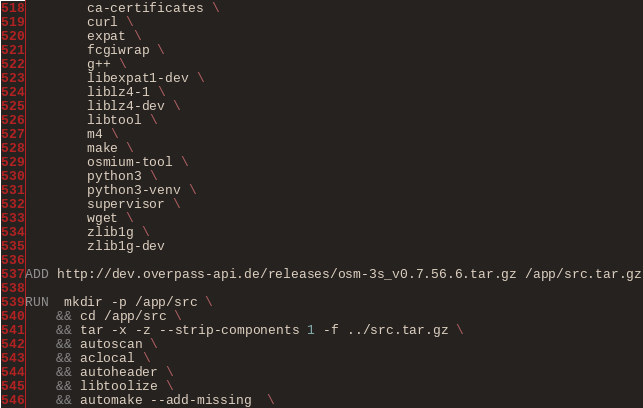<code> <loc_0><loc_0><loc_500><loc_500><_Dockerfile_>        ca-certificates \
        curl \
        expat \
        fcgiwrap \
        g++ \
        libexpat1-dev \
        liblz4-1 \
        liblz4-dev \
        libtool \
        m4 \
        make \
        osmium-tool \
        python3 \
        python3-venv \
        supervisor \
        wget \
        zlib1g \
        zlib1g-dev

ADD http://dev.overpass-api.de/releases/osm-3s_v0.7.56.6.tar.gz /app/src.tar.gz

RUN  mkdir -p /app/src \
    && cd /app/src \
    && tar -x -z --strip-components 1 -f ../src.tar.gz \
    && autoscan \
    && aclocal \
    && autoheader \
    && libtoolize \
    && automake --add-missing  \</code> 